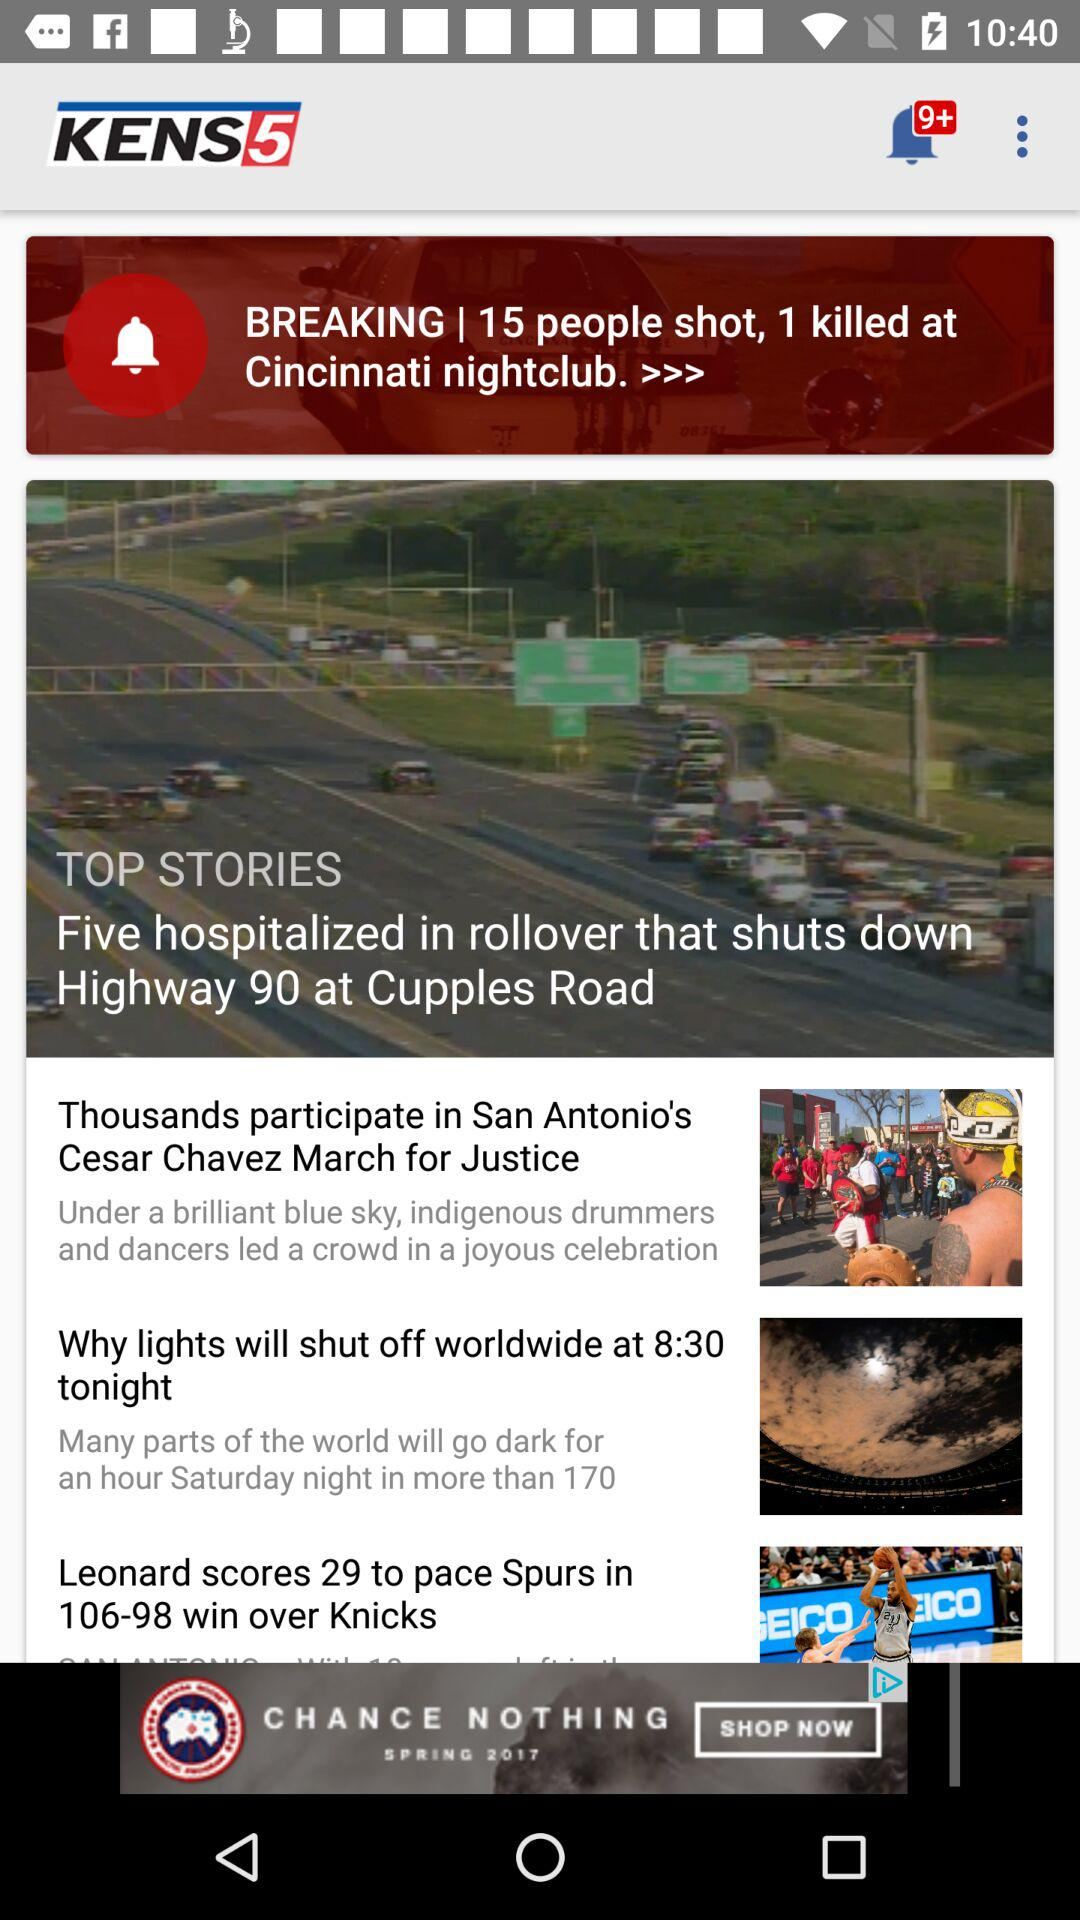How many people were killed at the "Cincinnati nightclub"? At the "Cincinnati nightclub", three people were killed. 